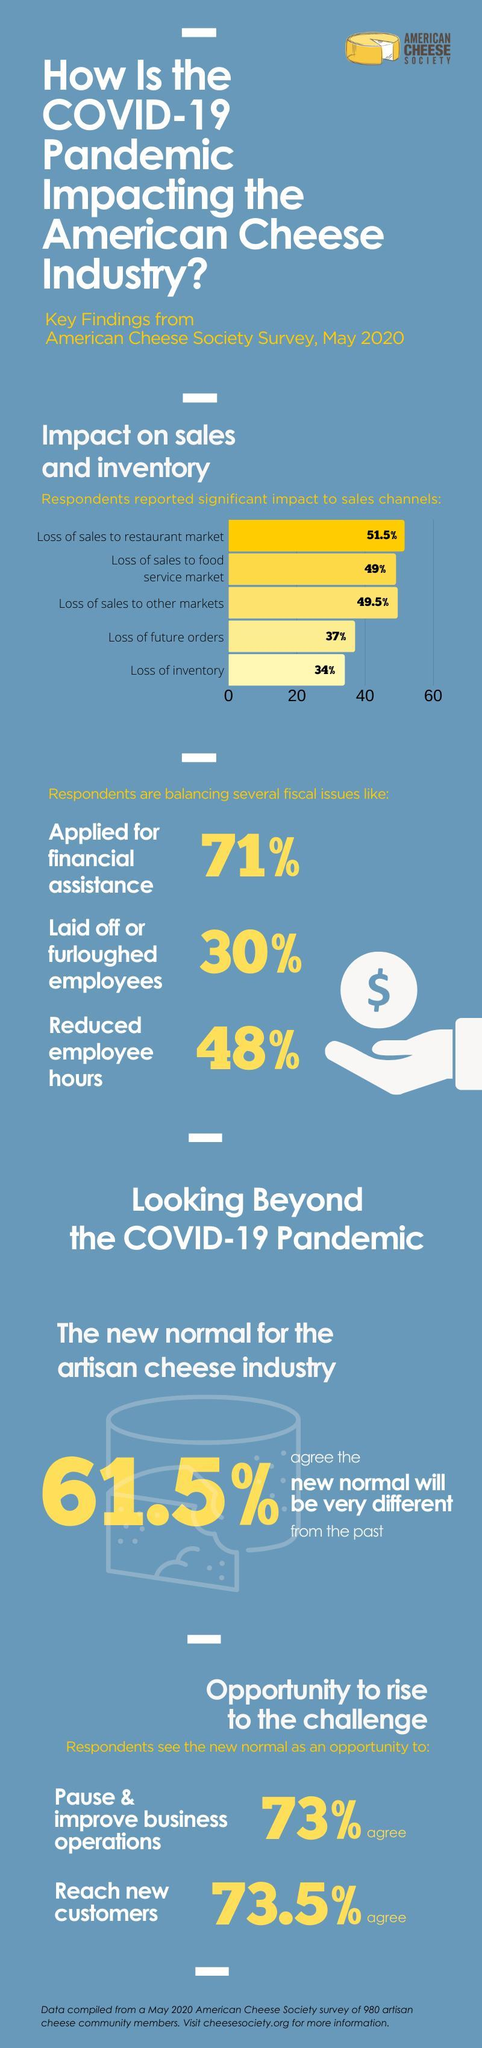What percent of respondents reported loss of inventory due to COVID-19 impact according to the American Cheese Society Survey, May 2020?
Answer the question with a short phrase. 34% What percent of respondents do not agree to see the new normal as an opportunity to reach new customers as per the American Cheese Society Survey, May 2020? 26.5% What percent of respondents reported loss of future orders due to COVID-19 impact according to the American Cheese Society Survey, May 2020? 37% What percent of respondents reported loss of sales to restaurant market due to COVID-19 impact according to the American Cheese Society Survey, May 2020? 51.5% What percent of respondents reported loss of sales to food service market due to COVID-19 impact  according to the American Cheese Society Survey, May 2020? 49% What percent of respondents didn't  apply for financial assistance during COVID-19 according to the American Cheese Society Survey, May 2020? 29% What percent of respondents didn't reduce employee hours during COVID-19 according to the American Cheese Society Survey, May 2020? 52% 